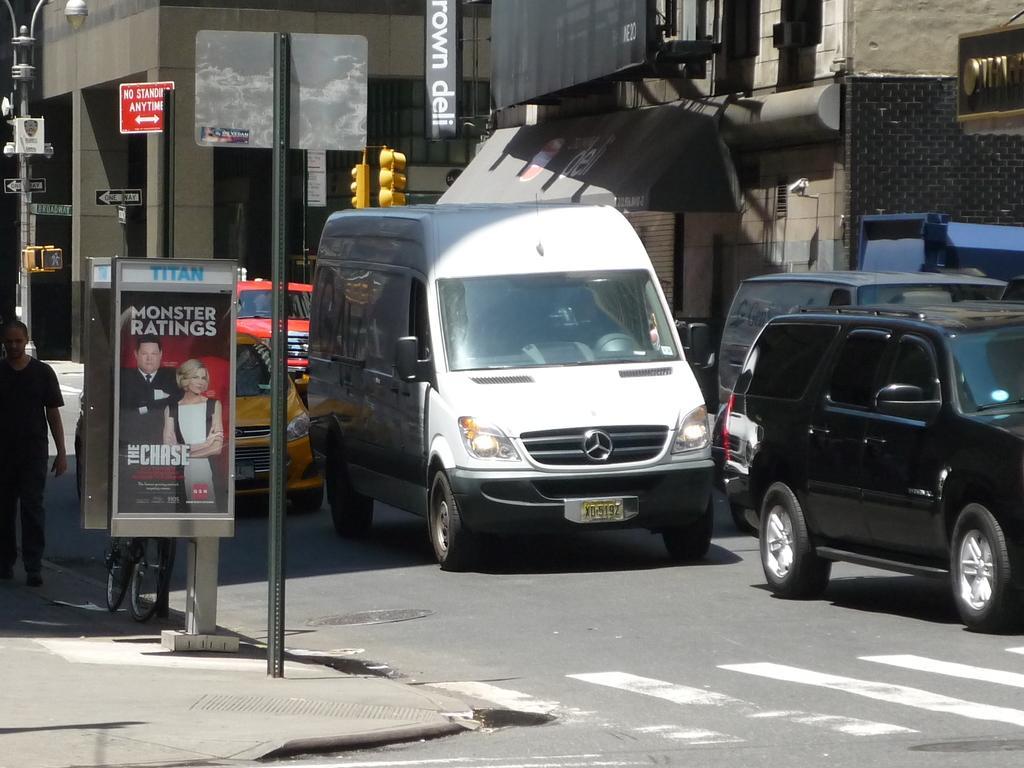Please provide a concise description of this image. In this picture we can see some vehicles, on the right side there are buildings, on the left side there is a person walking, we can also see a bicycle, a hoarding and a pole on the left side, we can see traffic lights, poles and sign boards in the middle. 